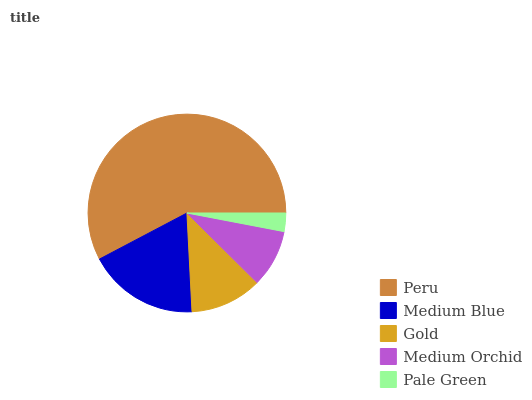Is Pale Green the minimum?
Answer yes or no. Yes. Is Peru the maximum?
Answer yes or no. Yes. Is Medium Blue the minimum?
Answer yes or no. No. Is Medium Blue the maximum?
Answer yes or no. No. Is Peru greater than Medium Blue?
Answer yes or no. Yes. Is Medium Blue less than Peru?
Answer yes or no. Yes. Is Medium Blue greater than Peru?
Answer yes or no. No. Is Peru less than Medium Blue?
Answer yes or no. No. Is Gold the high median?
Answer yes or no. Yes. Is Gold the low median?
Answer yes or no. Yes. Is Medium Orchid the high median?
Answer yes or no. No. Is Medium Orchid the low median?
Answer yes or no. No. 